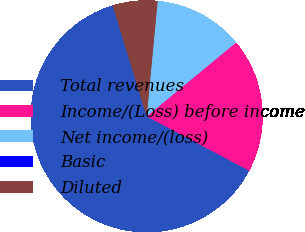Convert chart to OTSL. <chart><loc_0><loc_0><loc_500><loc_500><pie_chart><fcel>Total revenues<fcel>Income/(Loss) before income<fcel>Net income/(loss)<fcel>Basic<fcel>Diluted<nl><fcel>62.5%<fcel>18.75%<fcel>12.5%<fcel>0.0%<fcel>6.25%<nl></chart> 